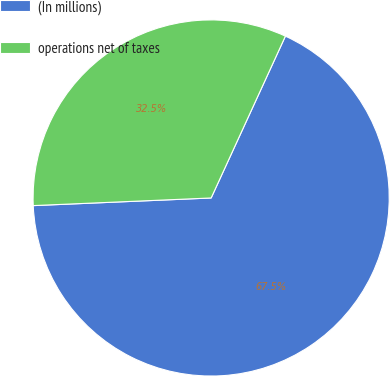Convert chart. <chart><loc_0><loc_0><loc_500><loc_500><pie_chart><fcel>(In millions)<fcel>operations net of taxes<nl><fcel>67.47%<fcel>32.53%<nl></chart> 